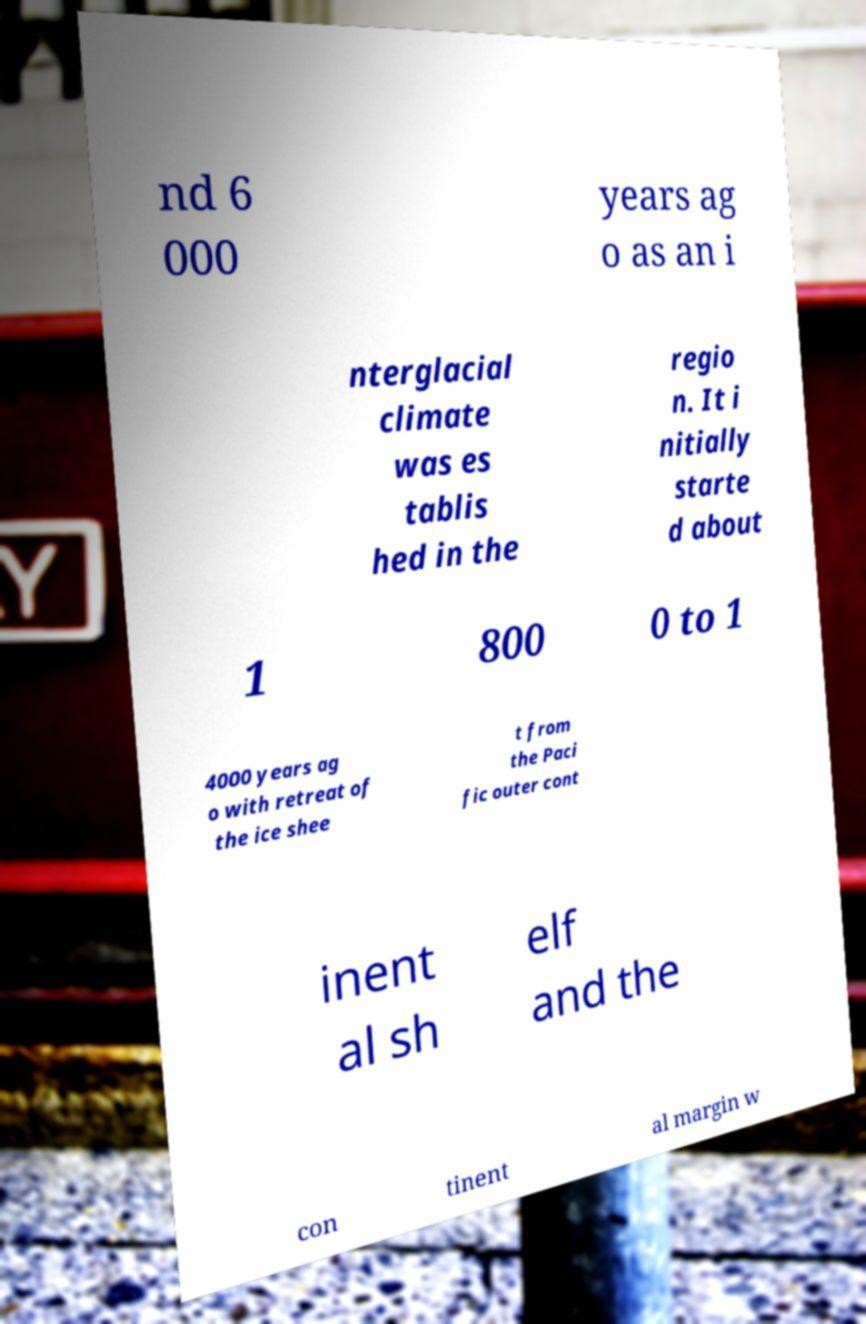What messages or text are displayed in this image? I need them in a readable, typed format. nd 6 000 years ag o as an i nterglacial climate was es tablis hed in the regio n. It i nitially starte d about 1 800 0 to 1 4000 years ag o with retreat of the ice shee t from the Paci fic outer cont inent al sh elf and the con tinent al margin w 